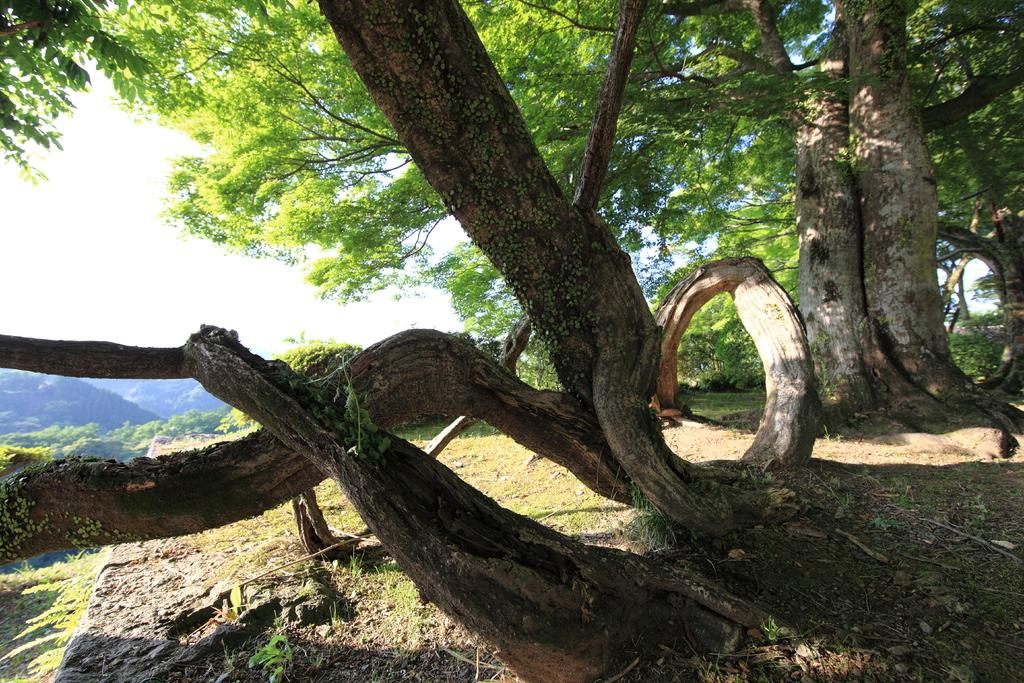What is the setting of the image? The image is an outside view. What can be seen on the ground in the image? There are many trees on the ground in the image. What part of the sky is visible in the image? The sky is visible on the left side of the image. What type of roof can be seen on the trees in the image? There are no roofs present on the trees in the image, as trees do not have roofs. 